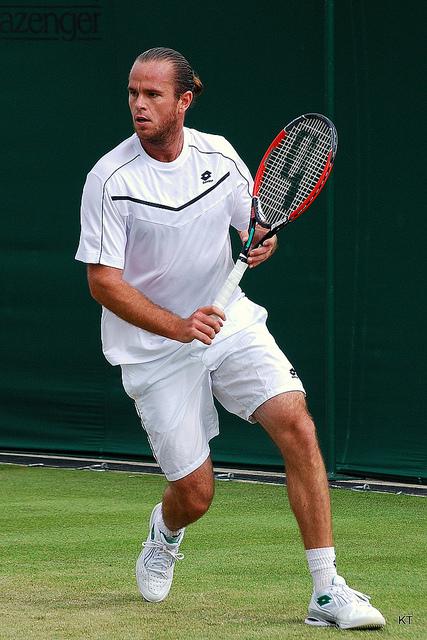What color is the player's hair?
Write a very short answer. Brown. Where is the man playing?
Quick response, please. Tennis court. What is he holding in his hands?
Give a very brief answer. Tennis racket. What type of shoes is the man wearing?
Keep it brief. Tennis. 